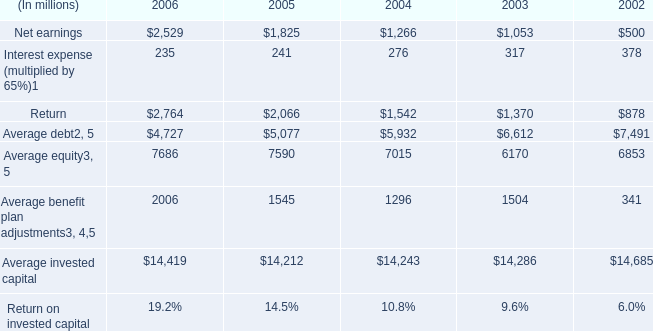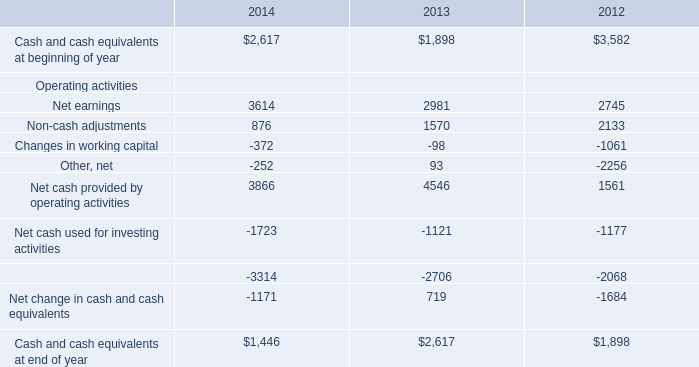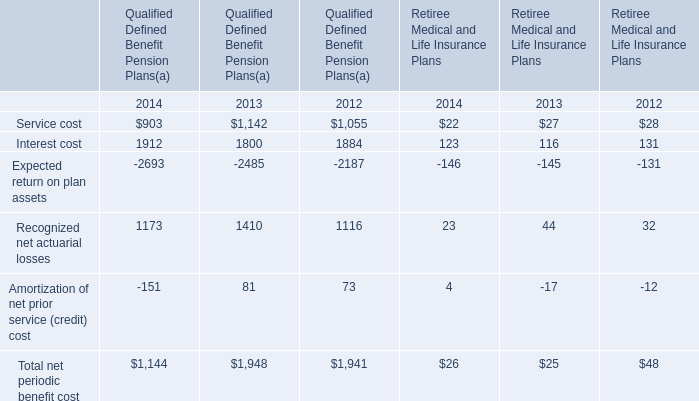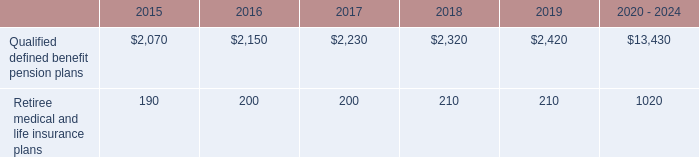What's the average of Average equity of 2005, and Interest cost of Qualified Defined Benefit Pension Plans 2013 ? 
Computations: ((7590.0 + 1800.0) / 2)
Answer: 4695.0. 